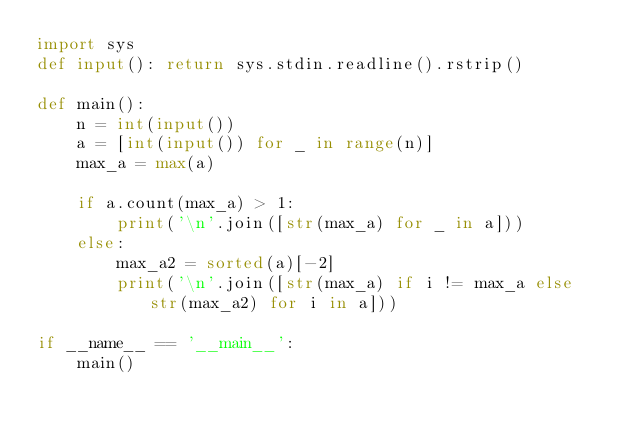<code> <loc_0><loc_0><loc_500><loc_500><_Python_>import sys
def input(): return sys.stdin.readline().rstrip()

def main():
    n = int(input())
    a = [int(input()) for _ in range(n)]
    max_a = max(a)

    if a.count(max_a) > 1:
        print('\n'.join([str(max_a) for _ in a]))
    else:
        max_a2 = sorted(a)[-2]
        print('\n'.join([str(max_a) if i != max_a else str(max_a2) for i in a]))

if __name__ == '__main__':
    main()
</code> 